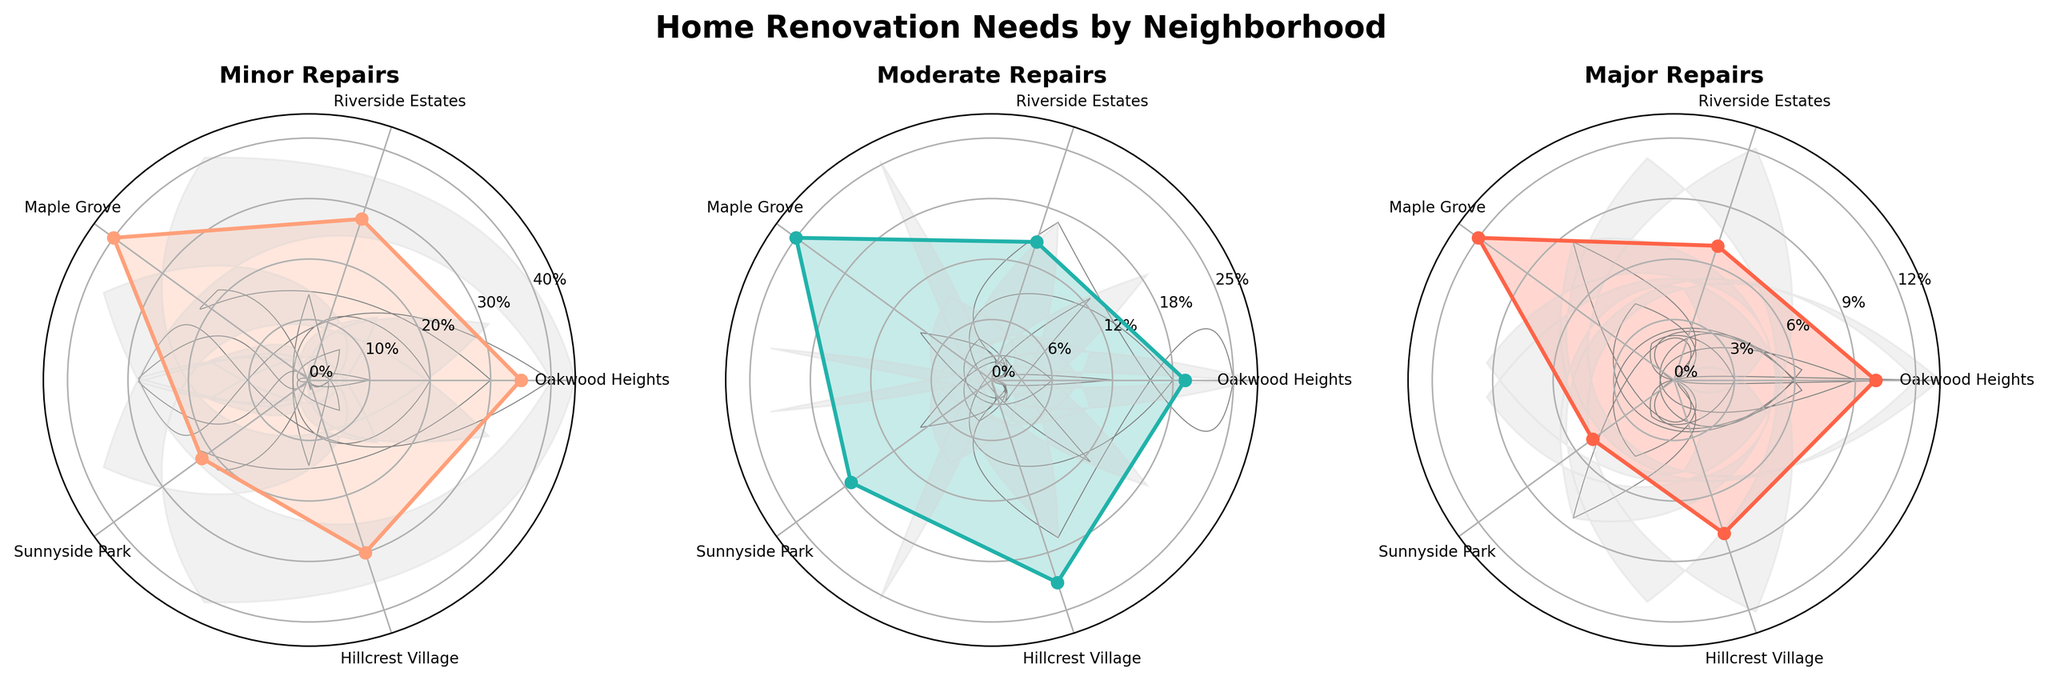What's the title of the figure? The figure's title is located at the top center and often displayed in bold to indicate the main topic of the chart.
Answer: Home Renovation Needs by Neighborhood How many categories of repairs are shown in the figure? By observing the chart, you can see that there are three distinct subplots, each representing a category of repairs.
Answer: Three Which neighborhood has the highest percentage of homes needing minor repairs? Look at the "Minor Repairs" subplot and compare the values corresponding to each neighborhood. Identify the highest value visually.
Answer: Maple Grove What is the percentage of homes needing major repairs in Hillcrest Village? Locate the "Major Repairs" subplot, find the data point for Hillcrest Village, and read off the corresponding percentage.
Answer: 8% Which neighborhood has the lowest percentage of homes needing moderate repairs? In the "Moderate Repairs" subplot, compare the values for each neighborhood and find the lowest one.
Answer: Riverside Estates What is the difference in percentage of homes needing minor repairs between Oakwood Heights and Sunnyside Park? Locate the values for Oakwood Heights and Sunnyside Park in the "Minor Repairs" subplot, then subtract the smaller value from the larger value. 35% - 22% = 13%
Answer: 13% Which category has the smallest maximum value across all neighborhoods? Compare the maximum values of the three subplots and identify the one with the smallest maximum.
Answer: Major Repairs In which category do Oakwood Heights and Riverside Estates differ the most in percentage? Calculate and compare the percentage differences between Oakwood Heights and Riverside Estates for each category: Minor Repairs: 35% - 28% = 7%, Moderate Repairs: 20% - 15% = 5%, Major Repairs: 10% - 7% = 3%.
Answer: Minor Repairs What is the average percentage of homes needing moderate repairs across all neighborhoods? Add the moderate repairs percentages of all neighborhoods and divide by the number of neighborhoods: (20 + 15 + 25 + 18 + 22) / 5 = 20%
Answer: 20% Which neighborhoods have a higher percentage of homes needing minor repairs than major repairs? For each neighborhood, compare the data points for minor and major repairs. List those where the minor repairs percentage is higher than the major repairs percentage.
Answer: Oakwood Heights, Riverside Estates, Maple Grove, Sunnyside Park, Hillcrest Village 